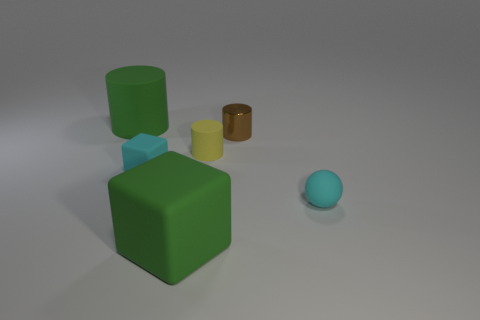Add 1 cyan spheres. How many objects exist? 7 Subtract all cubes. How many objects are left? 4 Add 2 small green shiny blocks. How many small green shiny blocks exist? 2 Subtract 0 blue balls. How many objects are left? 6 Subtract all large red metallic blocks. Subtract all small brown things. How many objects are left? 5 Add 3 tiny yellow rubber things. How many tiny yellow rubber things are left? 4 